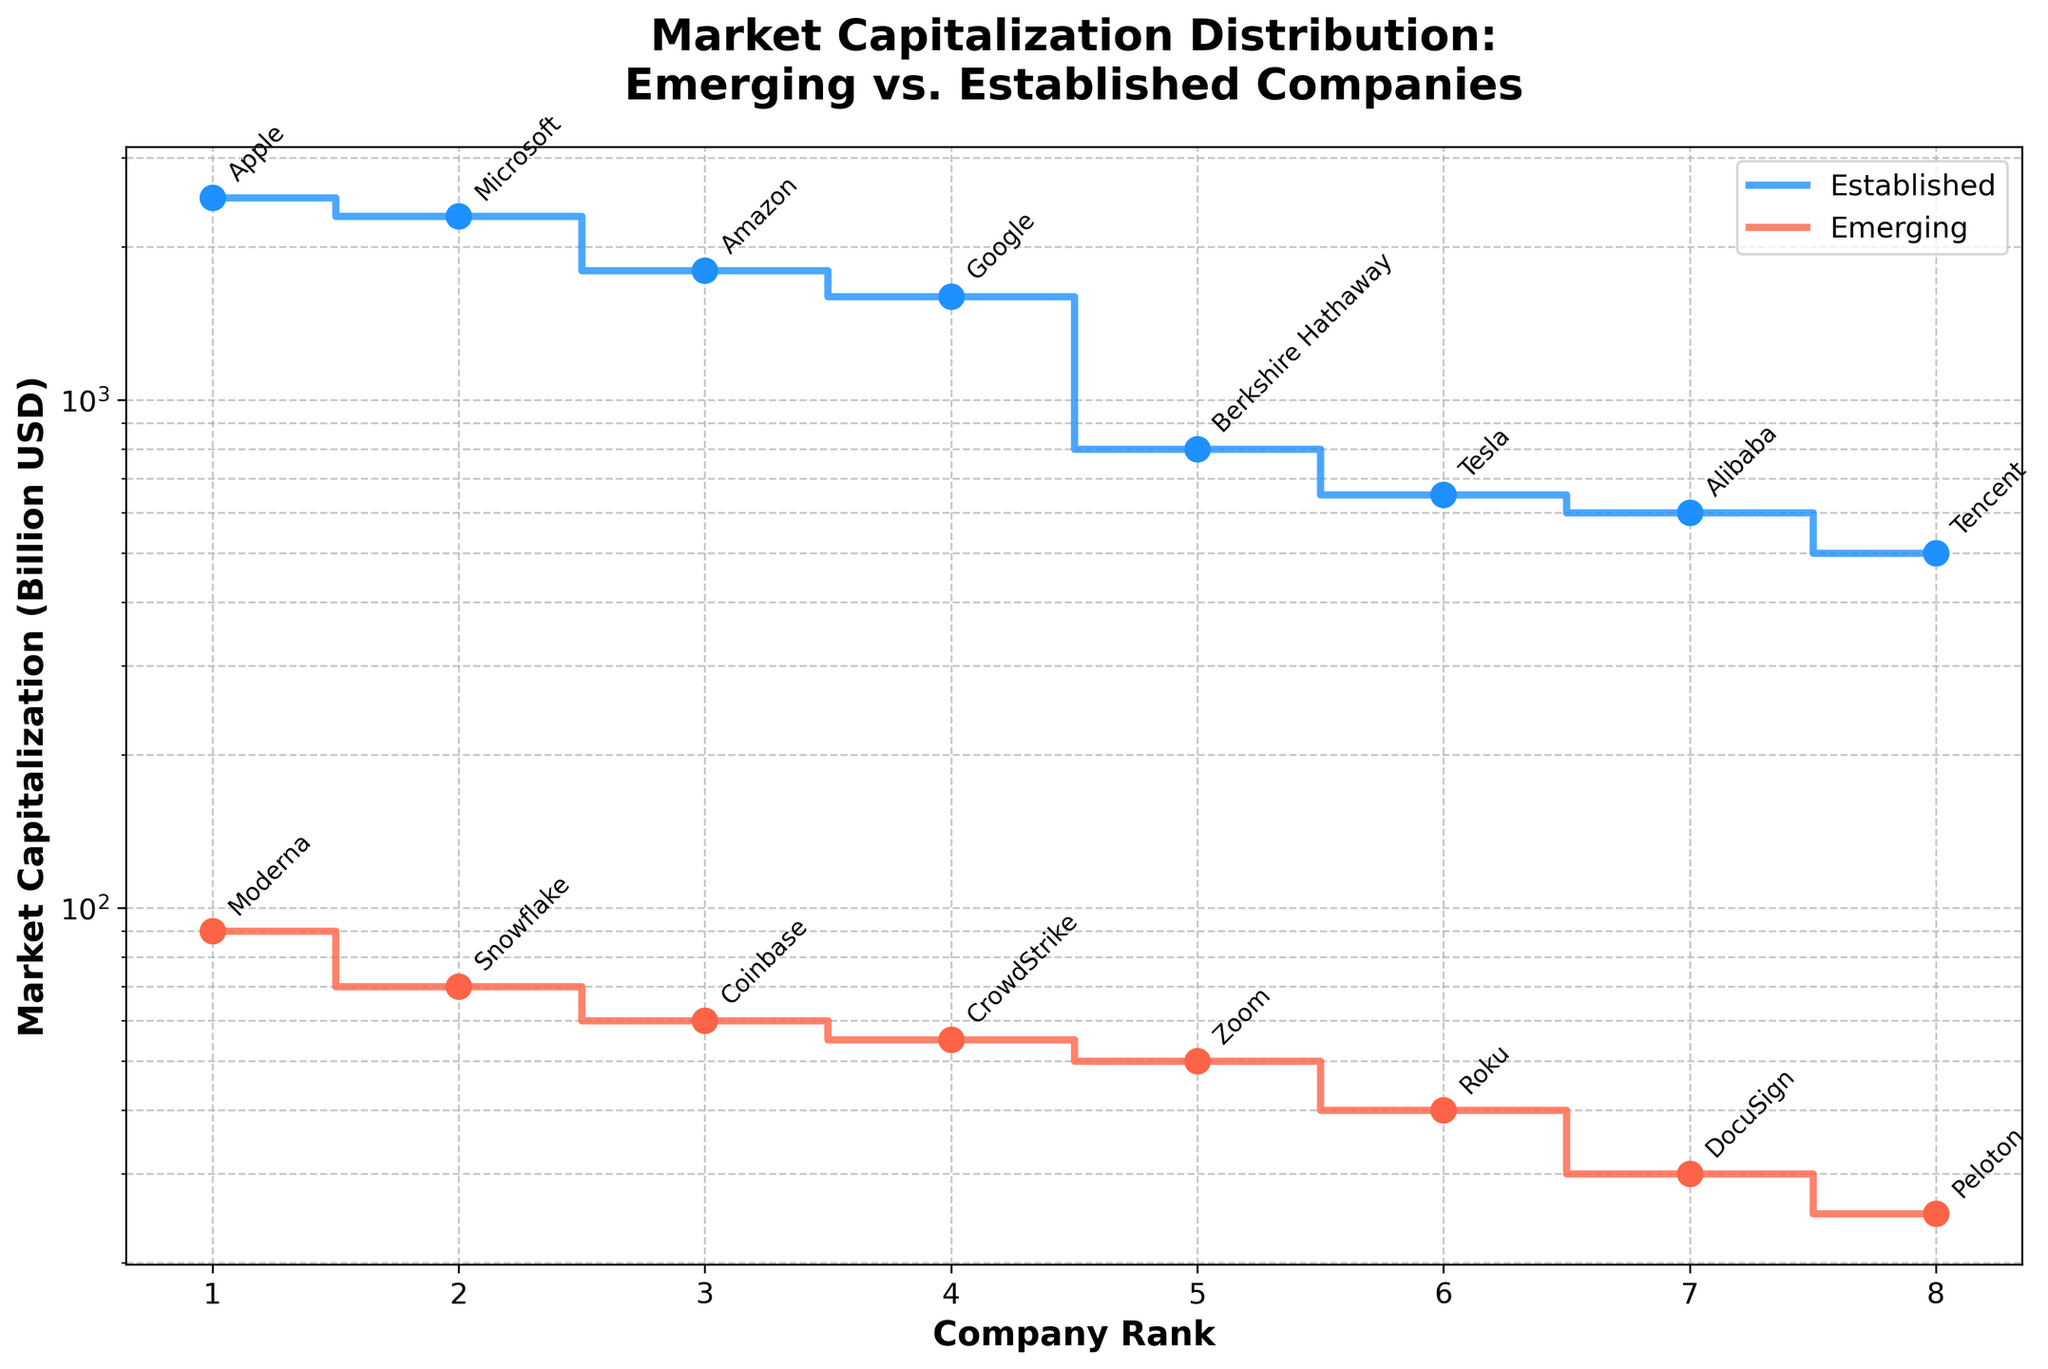What is the title of the plot? The title is usually the most prominent text on the plot, located at the top. In this case, it's the bolded text above the graph.
Answer: "Market Capitalization Distribution: Emerging vs. Established Companies" How many established companies are listed in the plot? The plot uses steps and dots to represent the data points. Counting the large blue dots or steps in the plot gives the number of established companies.
Answer: 8 Which company has the highest market capitalization among the emerging companies? The highest point in the red line (emerging companies) corresponds to the highest market cap. The annotation next to it shows the name.
Answer: Moderna What is the market capitalization of the smallest established company in the plot? The smallest market cap among established companies is the last point of the blue line. The annotation next to it shows the name and value on the y-axis.
Answer: $500 billion (Tencent) What's the ratio of the market cap of Apple to that of Tesla? Apple's market cap is given as $2500 billion and Tesla's as $650 billion. The ratio is calculated by dividing Apple's market cap by Tesla's.
Answer: $\frac{2500}{650} \approx 3.85$ How do the market caps of the top 3 established companies compare with the top 3 emerging companies? Identify the top three companies in both sections from the annotations and their market caps: Established (Apple $2500, Microsoft $2300, Amazon $1800), Emerging (Moderna $90, Snowflake $70, Coinbase $60). Then compare them.
Answer: Established companies have significantly higher market caps than emerging ones Which company ranks third among the emerging companies, and what is its market cap? Locate the third point in the red line and refer to the annotation for the name and market cap.
Answer: Snowflake, $70 billion Is the market capitalization distribution more spread out or concentrated among established or emerging companies? Compare the range and spacing of the steps (lines) for both groups. The wider spread indicates a more varied distribution.
Answer: More spread out among established companies How many companies have a market cap between $50 billion and $70 billion? Look for points within the $50 billion and $70 billion range on the y-axis and count the annotations.
Answer: 3 (Snowflake, CrowdStrike, Coinbase) Which established company has a lower market cap than Alibaba but higher than Berkshire Hathaway? Refer to the steps between Alibaba and Berkshire Hathaway and check the annotation.
Answer: Tesla 